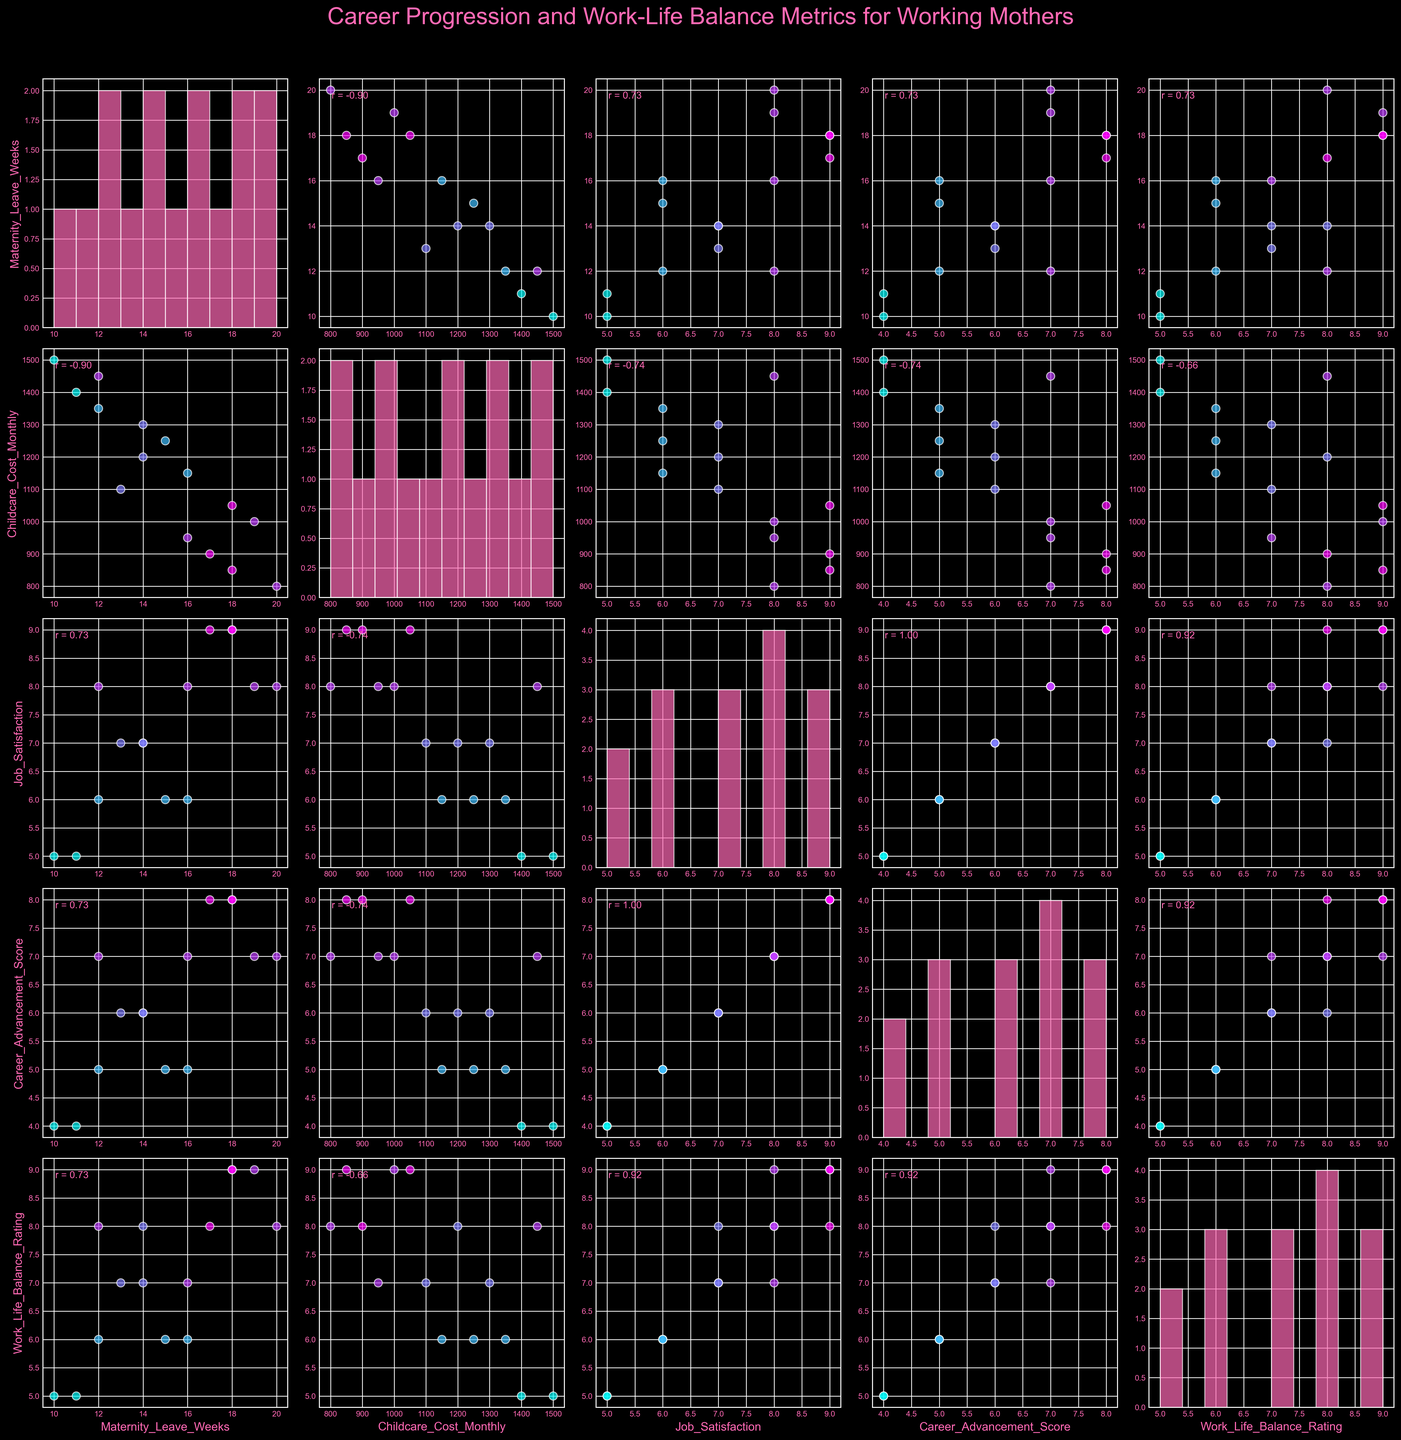What's the title of this scatterplot matrix? The title is located at the top center of the scatterplot matrix.
Answer: Career Progression and Work-Life Balance Metrics for Working Mothers What does the color of the data points represent? The colors of the data points vary, indicating different levels of job satisfaction. Cooler colors represent lower job satisfaction, while warmer colors signify higher satisfaction.
Answer: Job satisfaction levels Which variable appears on the histogram in the first diagonal cell? The first diagonal cell contains a histogram of the first variable listed in the columns.
Answer: Maternity Leave Weeks Is there a positive or negative correlation between Maternity Leave Weeks and Job Satisfaction? By inspecting the scatterplot for Maternity Leave Weeks versus Job Satisfaction, observe the trend and the correlation coefficient displayed within the plot.
Answer: Positive correlation Which two variables have the highest correlation coefficient, and what is its value? By comparing the correlation coefficients displayed in the off-diagonal scatterplots, identify the highest value.
Answer: Career Advancement Score and Job Satisfaction, r ≈ 0.95 What is the shape of the distribution for childcare costs? Check the histogram for Childcare Cost Monthly in the diagonal cells to observe its distribution.
Answer: Positively skewed Do higher Career Advancement Scores generally correlate with higher Job Satisfaction levels? Look at the scatterplot between Career Advancement Score and Job Satisfaction and observe the trend of the points and the correlation coefficient provided.
Answer: Yes What is the approximate number of data points used to generate this figure? Counting the number of distinct points in any scatterplot gives the number of data points. Verify by checking several scatterplots for consistency.
Answer: 15 How does the Work-Life Balance Rating correlate with Childcare Cost Monthly? By examining the scatterplot for Work-Life Balance Rating versus Childcare Cost Monthly, observe the trend and the correlation coefficient provided within the scatterplot.
Answer: Negative correlation What is the color scheme used for the scatter plots? By reviewing the coloring of data points across all scatterplots, deduce the color scheme used.
Answer: Cool colors (blue to pink range) 